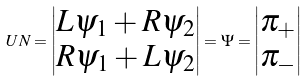Convert formula to latex. <formula><loc_0><loc_0><loc_500><loc_500>U N = \left | \begin{matrix} L \psi _ { 1 } + R \psi _ { 2 } \\ R \psi _ { 1 } + L \psi _ { 2 } \end{matrix} \right | = \Psi = \left | \begin{matrix} \pi _ { + } \\ \pi _ { - } \end{matrix} \right |</formula> 